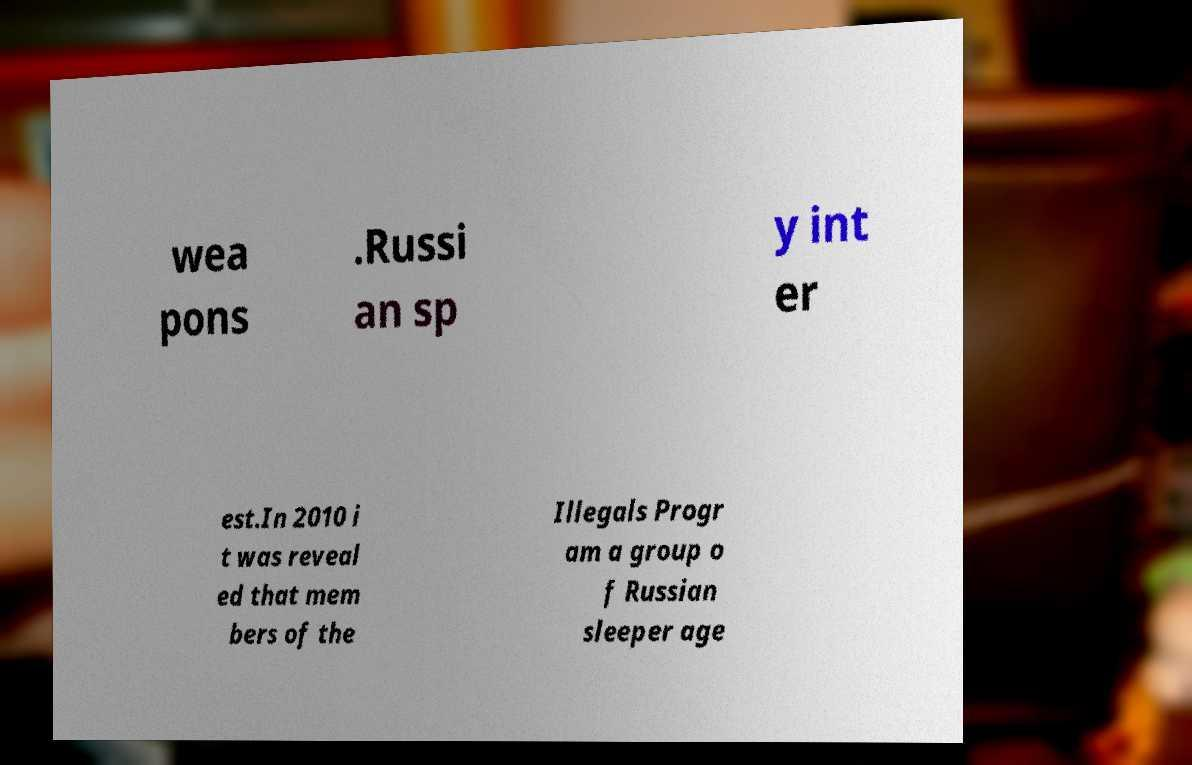I need the written content from this picture converted into text. Can you do that? wea pons .Russi an sp y int er est.In 2010 i t was reveal ed that mem bers of the Illegals Progr am a group o f Russian sleeper age 